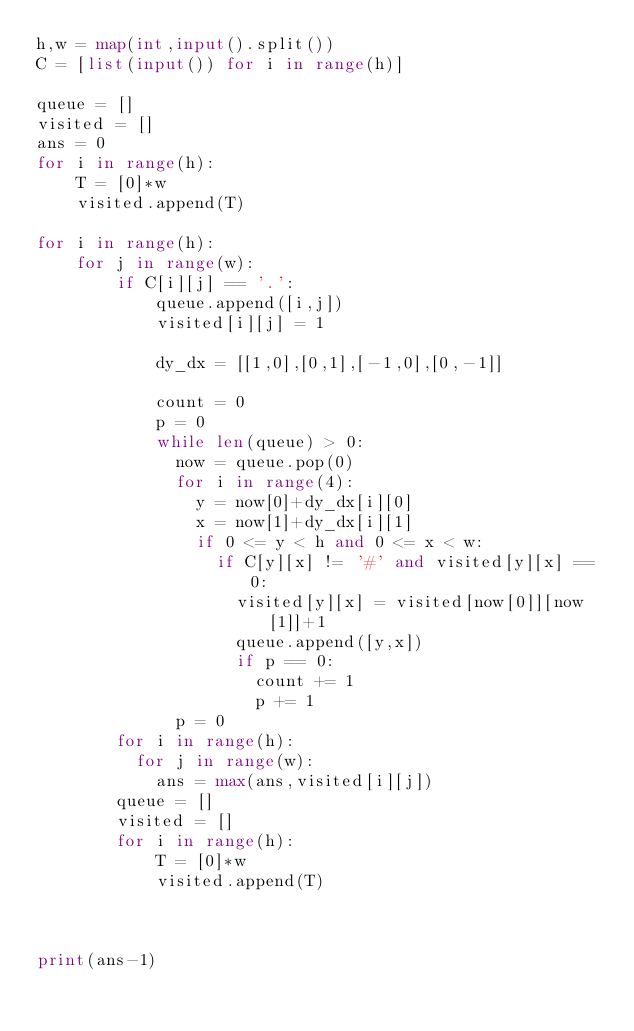<code> <loc_0><loc_0><loc_500><loc_500><_Python_>h,w = map(int,input().split())
C = [list(input()) for i in range(h)]

queue = []
visited = [] 
ans = 0
for i in range(h):
    T = [0]*w
    visited.append(T) 
    
for i in range(h):
    for j in range(w):
        if C[i][j] == '.':
            queue.append([i,j])
            visited[i][j] = 1

            dy_dx = [[1,0],[0,1],[-1,0],[0,-1]]

            count = 0
            p = 0
            while len(queue) > 0:
              now = queue.pop(0)
              for i in range(4):
                y = now[0]+dy_dx[i][0]
                x = now[1]+dy_dx[i][1]
                if 0 <= y < h and 0 <= x < w:
                  if C[y][x] != '#' and visited[y][x] == 0:
                    visited[y][x] = visited[now[0]][now[1]]+1
                    queue.append([y,x])
                    if p == 0:
                      count += 1
                      p += 1
              p = 0
        for i in range(h):
          for j in range(w):
            ans = max(ans,visited[i][j])
        queue = []
        visited = []  
        for i in range(h):
            T = [0]*w
            visited.append(T) 
       
            
        
print(ans-1)</code> 